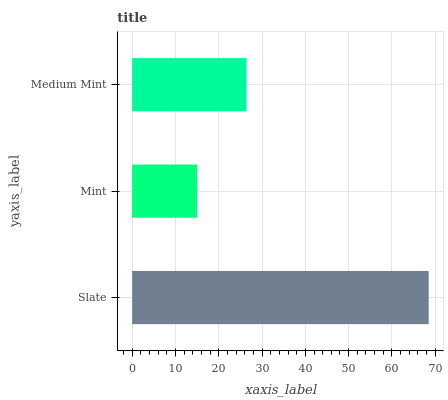Is Mint the minimum?
Answer yes or no. Yes. Is Slate the maximum?
Answer yes or no. Yes. Is Medium Mint the minimum?
Answer yes or no. No. Is Medium Mint the maximum?
Answer yes or no. No. Is Medium Mint greater than Mint?
Answer yes or no. Yes. Is Mint less than Medium Mint?
Answer yes or no. Yes. Is Mint greater than Medium Mint?
Answer yes or no. No. Is Medium Mint less than Mint?
Answer yes or no. No. Is Medium Mint the high median?
Answer yes or no. Yes. Is Medium Mint the low median?
Answer yes or no. Yes. Is Mint the high median?
Answer yes or no. No. Is Mint the low median?
Answer yes or no. No. 